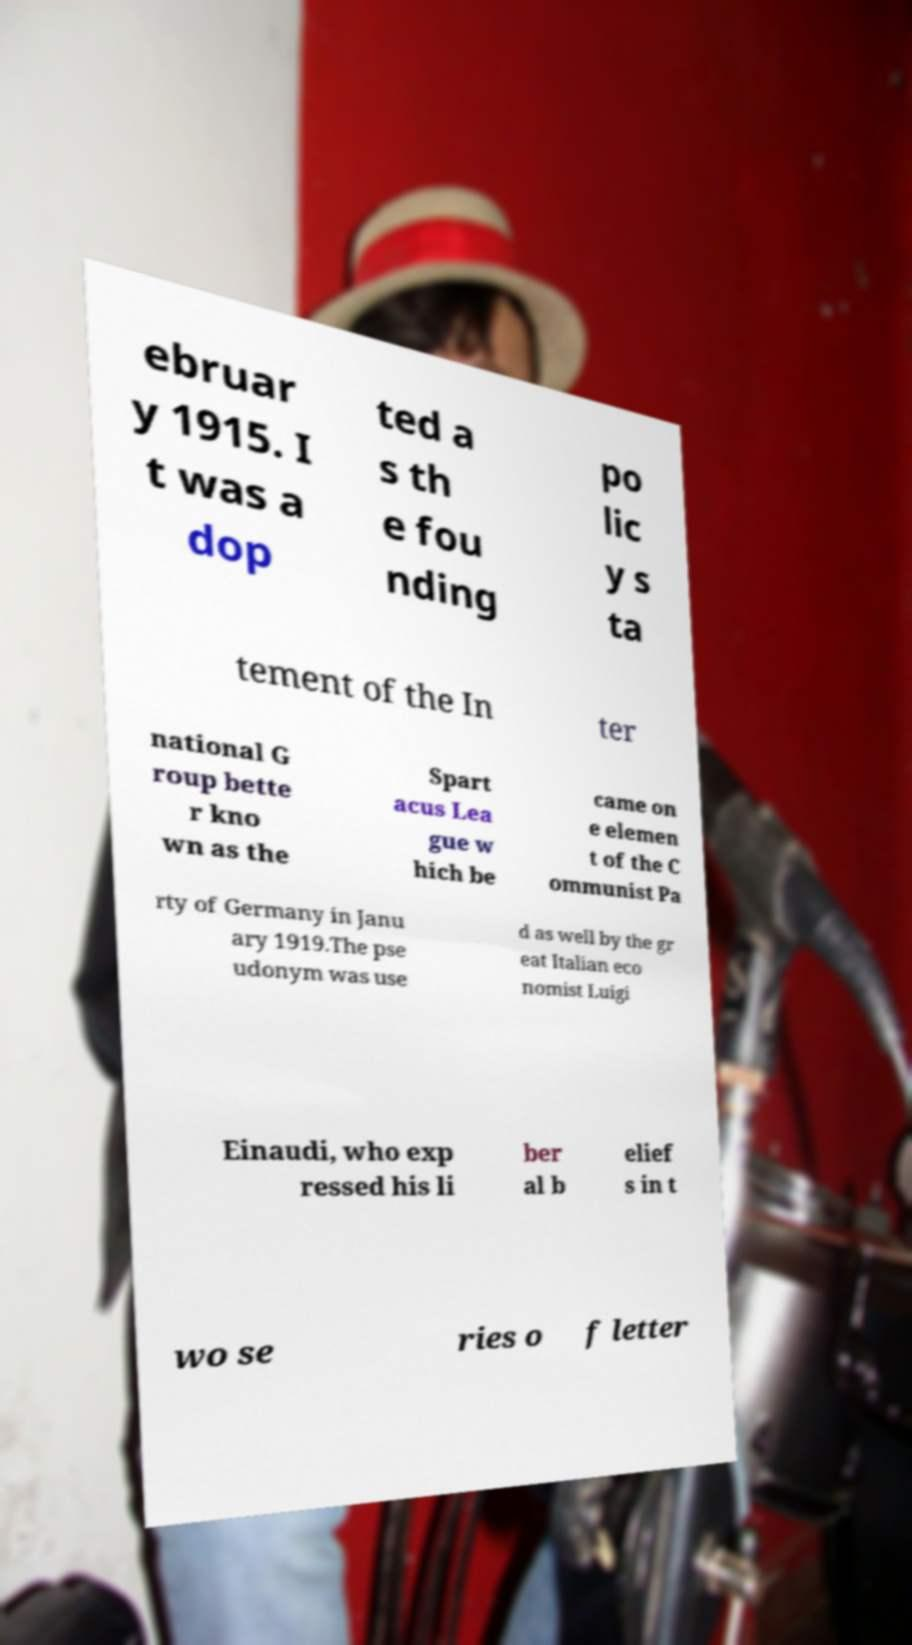Please read and relay the text visible in this image. What does it say? ebruar y 1915. I t was a dop ted a s th e fou nding po lic y s ta tement of the In ter national G roup bette r kno wn as the Spart acus Lea gue w hich be came on e elemen t of the C ommunist Pa rty of Germany in Janu ary 1919.The pse udonym was use d as well by the gr eat Italian eco nomist Luigi Einaudi, who exp ressed his li ber al b elief s in t wo se ries o f letter 